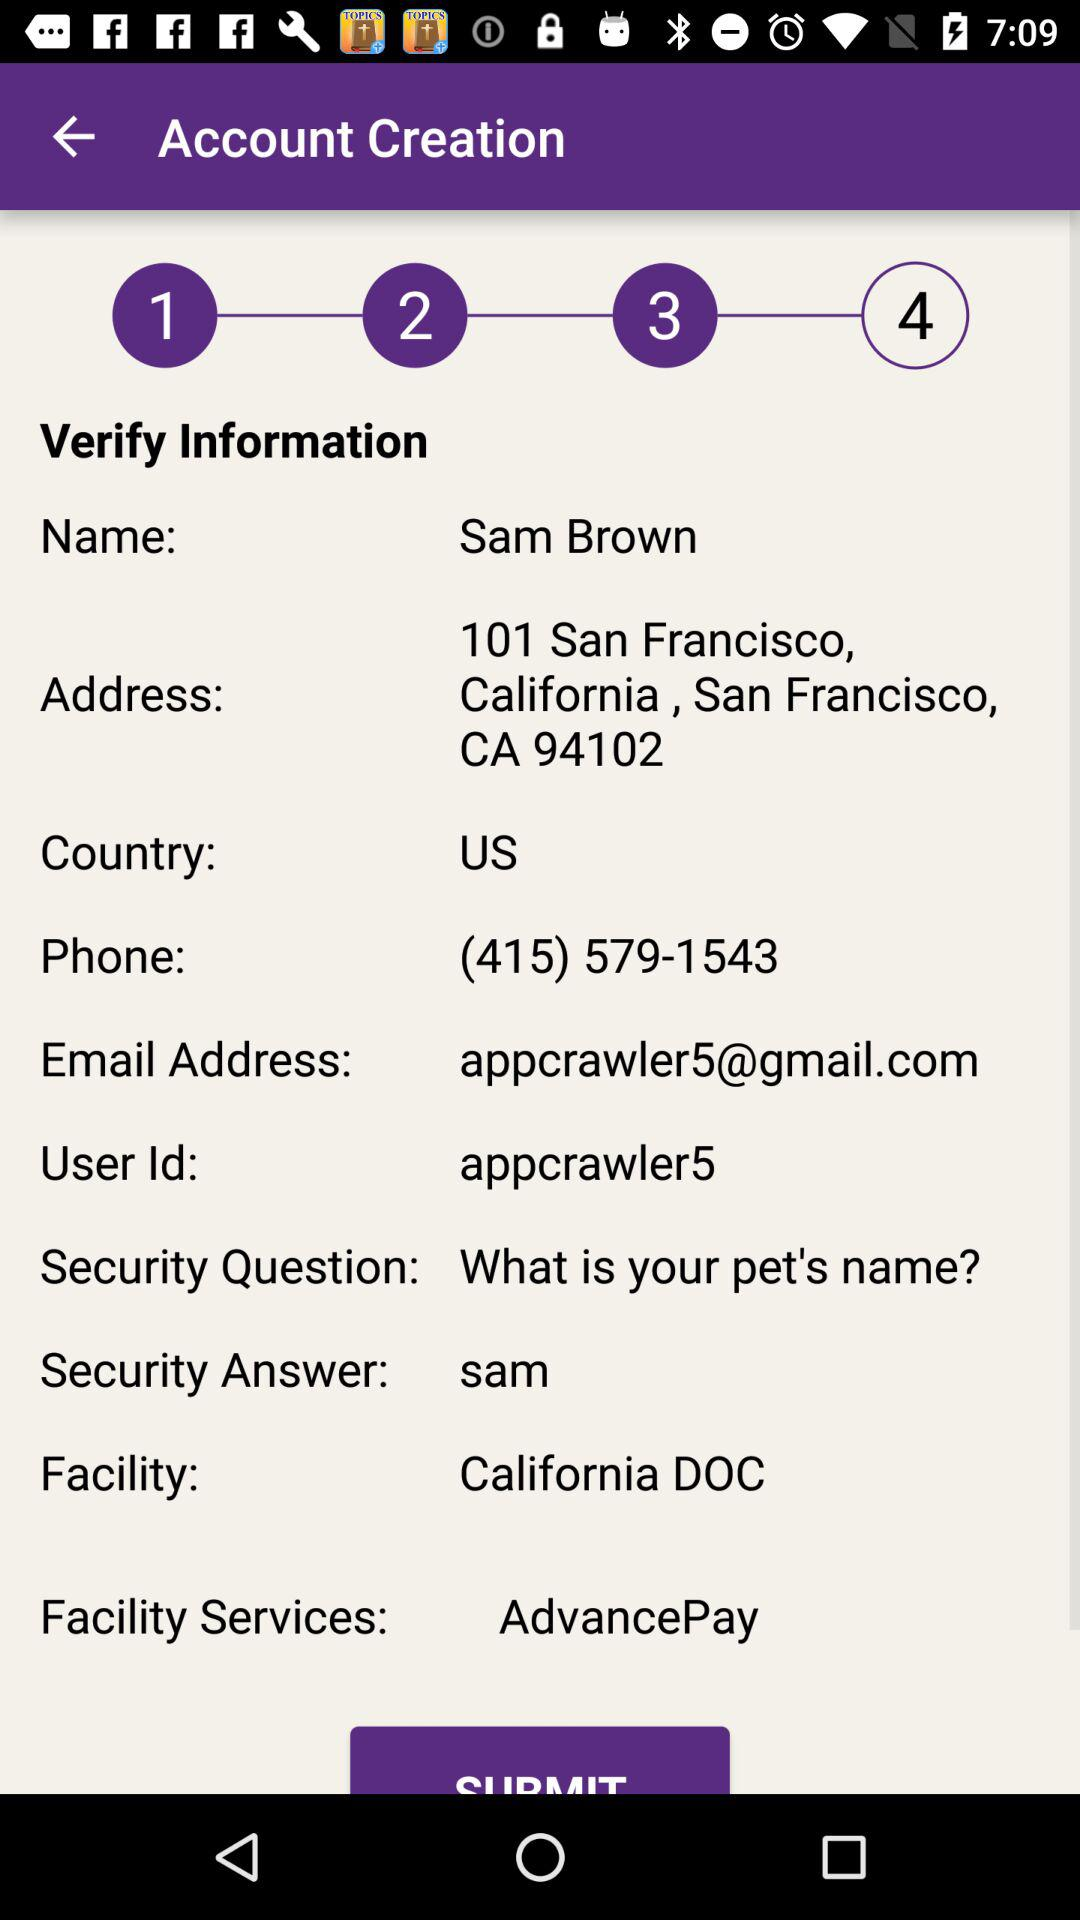What is the security question? The security question is "What is your pet's name?". 